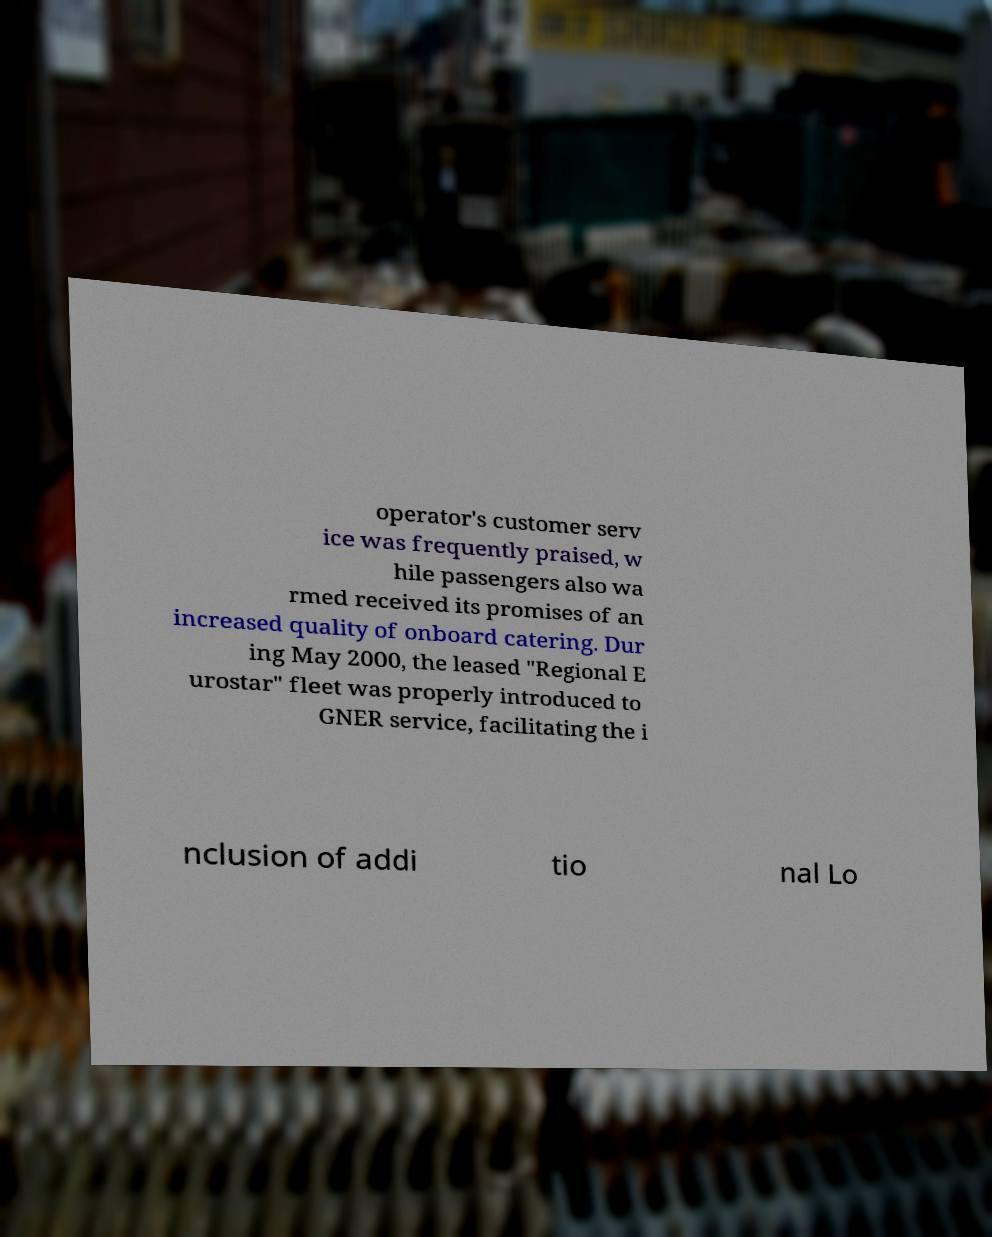Please read and relay the text visible in this image. What does it say? operator's customer serv ice was frequently praised, w hile passengers also wa rmed received its promises of an increased quality of onboard catering. Dur ing May 2000, the leased "Regional E urostar" fleet was properly introduced to GNER service, facilitating the i nclusion of addi tio nal Lo 